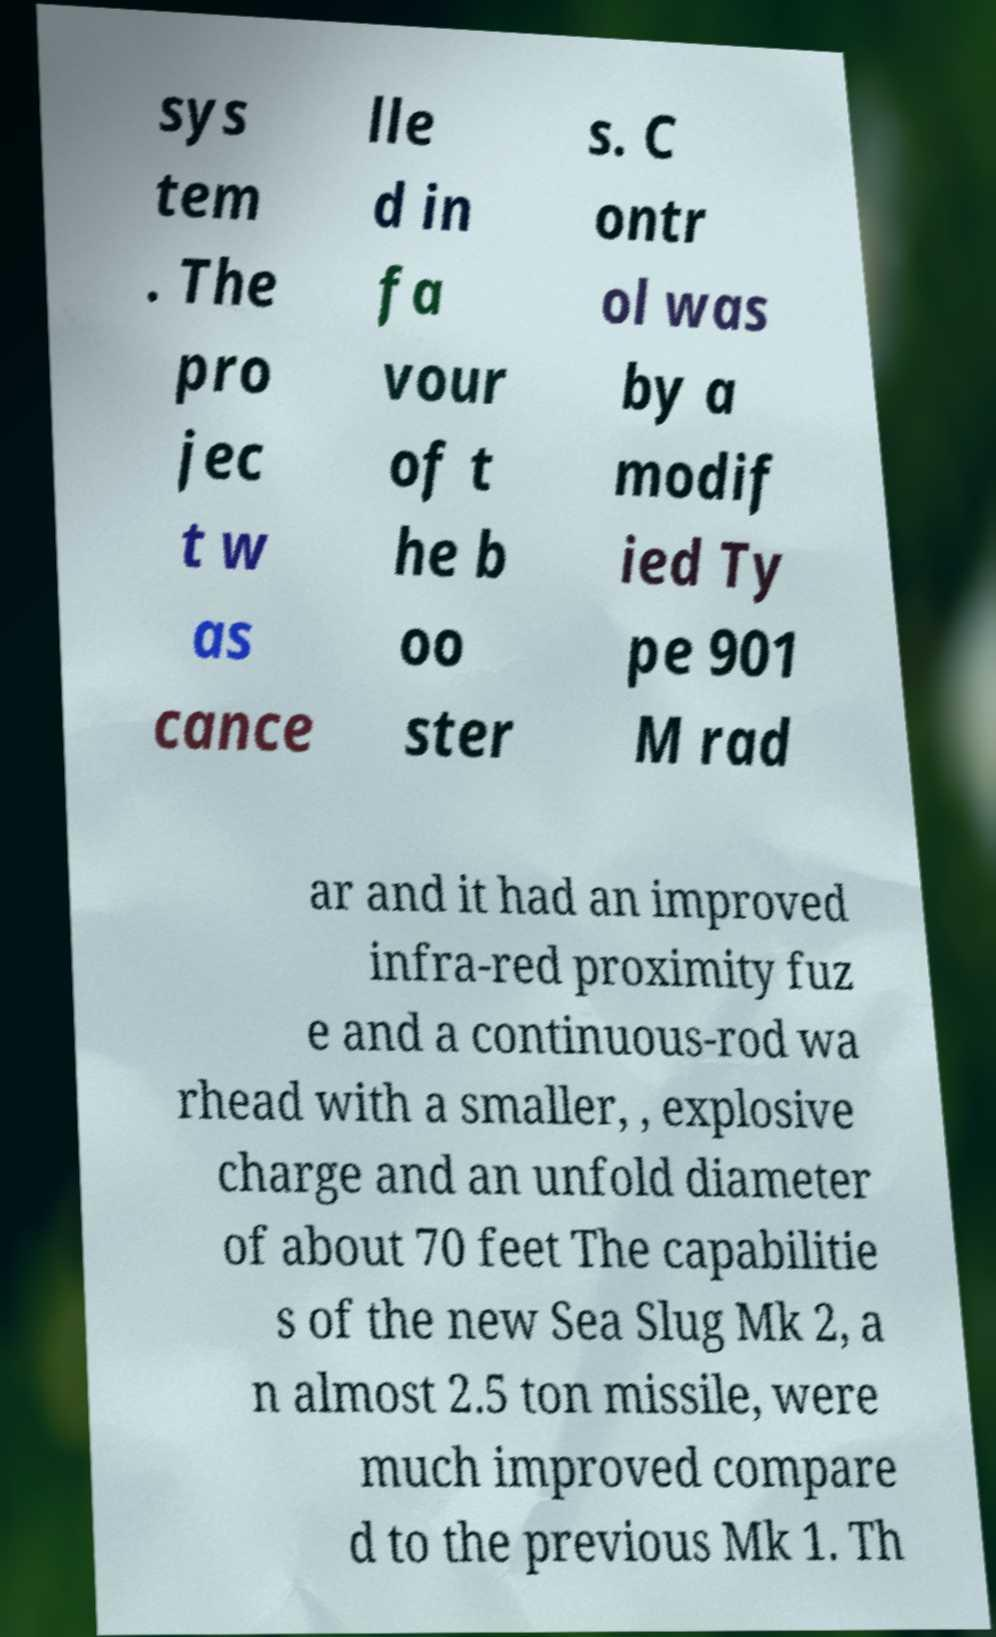Could you assist in decoding the text presented in this image and type it out clearly? sys tem . The pro jec t w as cance lle d in fa vour of t he b oo ster s. C ontr ol was by a modif ied Ty pe 901 M rad ar and it had an improved infra-red proximity fuz e and a continuous-rod wa rhead with a smaller, , explosive charge and an unfold diameter of about 70 feet The capabilitie s of the new Sea Slug Mk 2, a n almost 2.5 ton missile, were much improved compare d to the previous Mk 1. Th 